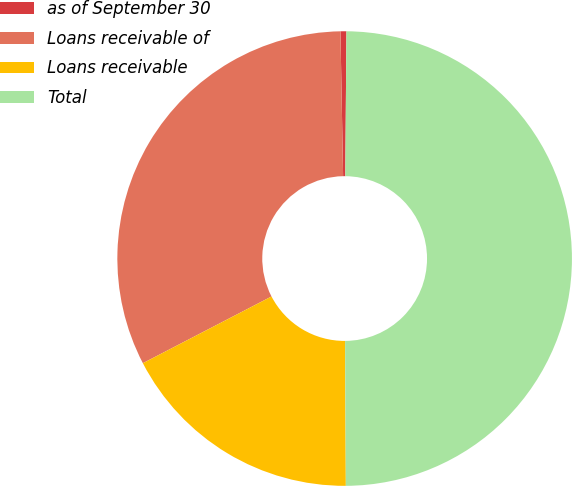<chart> <loc_0><loc_0><loc_500><loc_500><pie_chart><fcel>as of September 30<fcel>Loans receivable of<fcel>Loans receivable<fcel>Total<nl><fcel>0.42%<fcel>32.32%<fcel>17.47%<fcel>49.79%<nl></chart> 